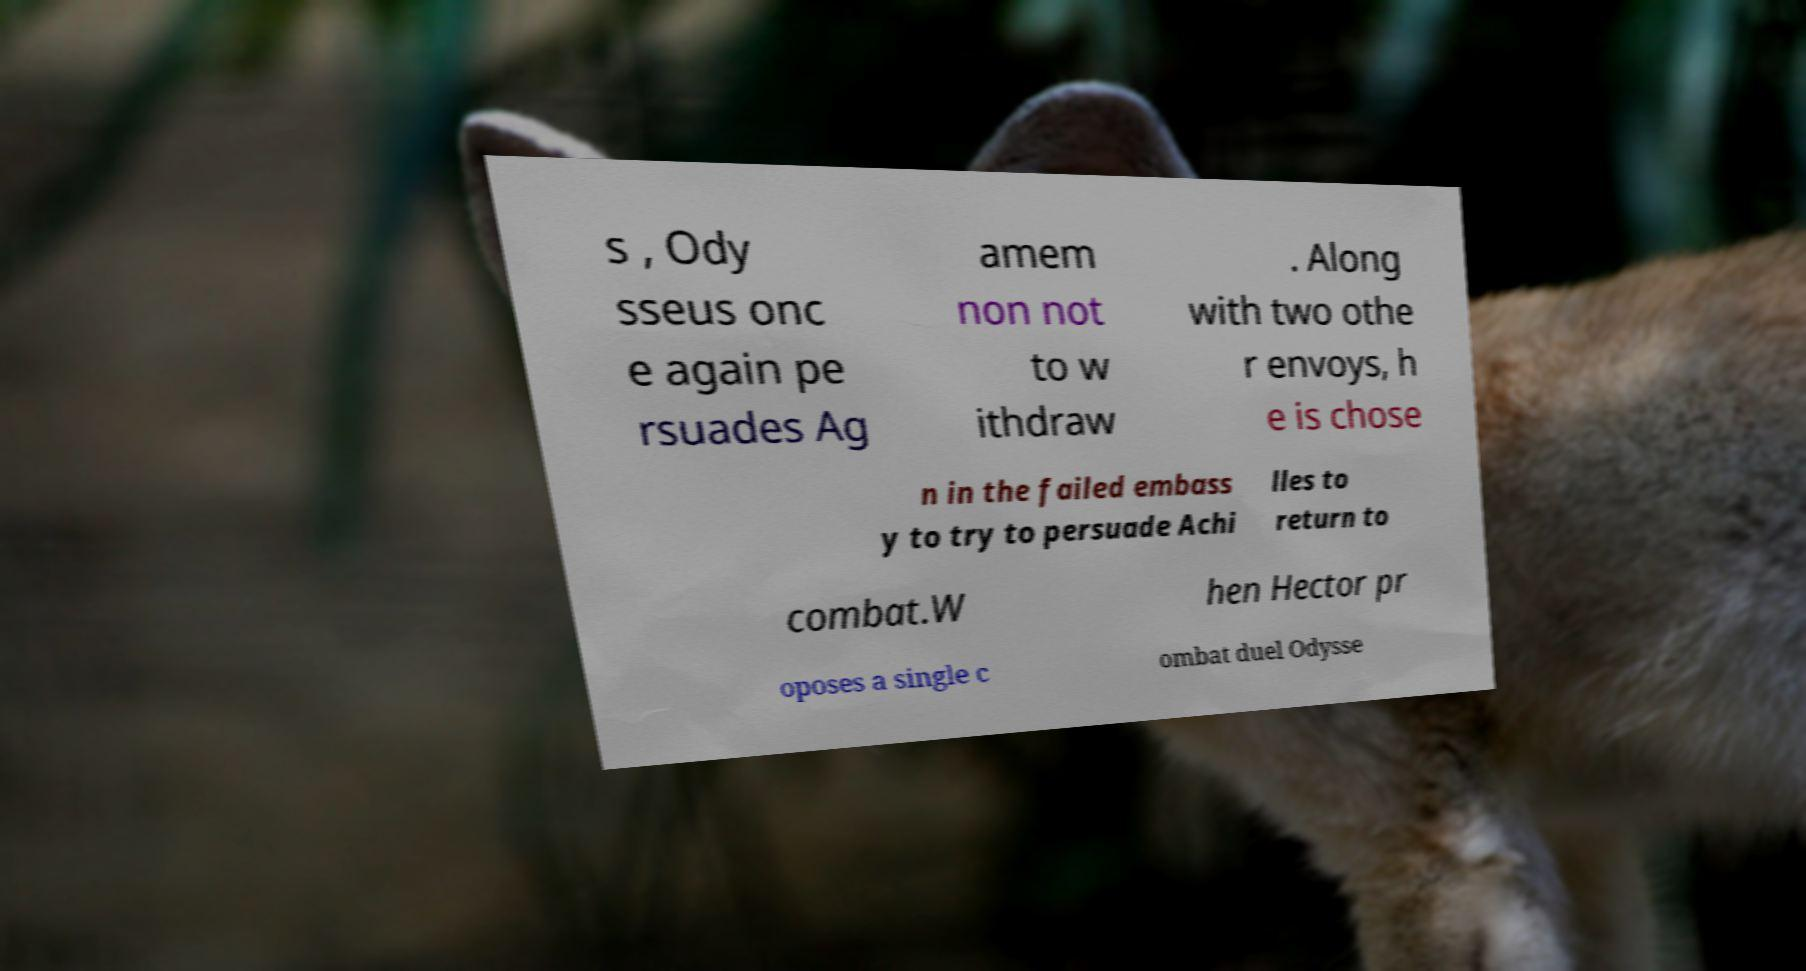Could you extract and type out the text from this image? s , Ody sseus onc e again pe rsuades Ag amem non not to w ithdraw . Along with two othe r envoys, h e is chose n in the failed embass y to try to persuade Achi lles to return to combat.W hen Hector pr oposes a single c ombat duel Odysse 